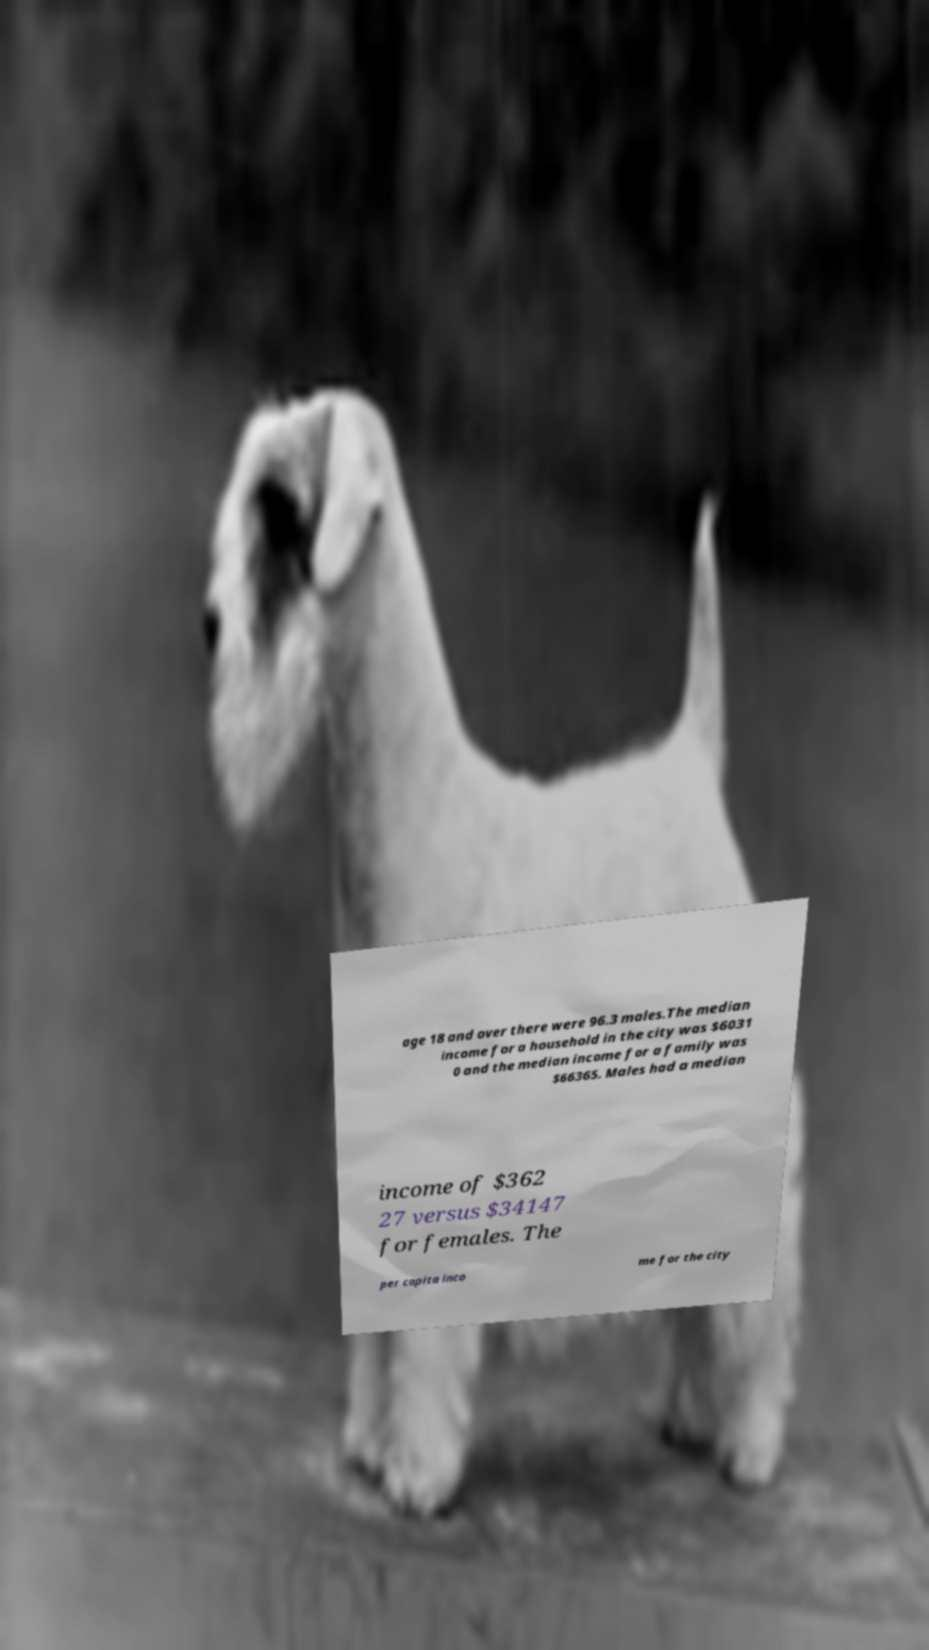There's text embedded in this image that I need extracted. Can you transcribe it verbatim? age 18 and over there were 96.3 males.The median income for a household in the city was $6031 0 and the median income for a family was $66365. Males had a median income of $362 27 versus $34147 for females. The per capita inco me for the city 